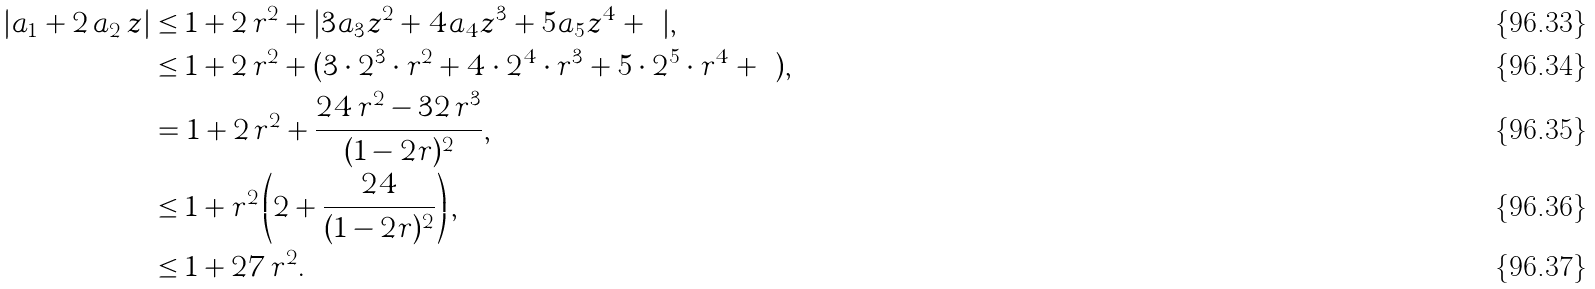<formula> <loc_0><loc_0><loc_500><loc_500>| a _ { 1 } + 2 \, a _ { 2 } \, z | & \leq 1 + 2 \, r ^ { 2 } + | 3 a _ { 3 } z ^ { 2 } + 4 a _ { 4 } z ^ { 3 } + 5 a _ { 5 } z ^ { 4 } + \cdots | , \\ & \leq 1 + 2 \, r ^ { 2 } + ( 3 \cdot 2 ^ { 3 } \cdot r ^ { 2 } + 4 \cdot 2 ^ { 4 } \cdot r ^ { 3 } + 5 \cdot 2 ^ { 5 } \cdot r ^ { 4 } + \cdots ) , \\ & = 1 + 2 \, r ^ { 2 } + \frac { 2 4 \, r ^ { 2 } - 3 2 \, r ^ { 3 } } { ( 1 - 2 r ) ^ { 2 } } , \\ & \leq 1 + r ^ { 2 } \left ( 2 + \frac { 2 4 } { ( 1 - 2 r ) ^ { 2 } } \right ) , \\ & \leq 1 + 2 7 \, r ^ { 2 } .</formula> 